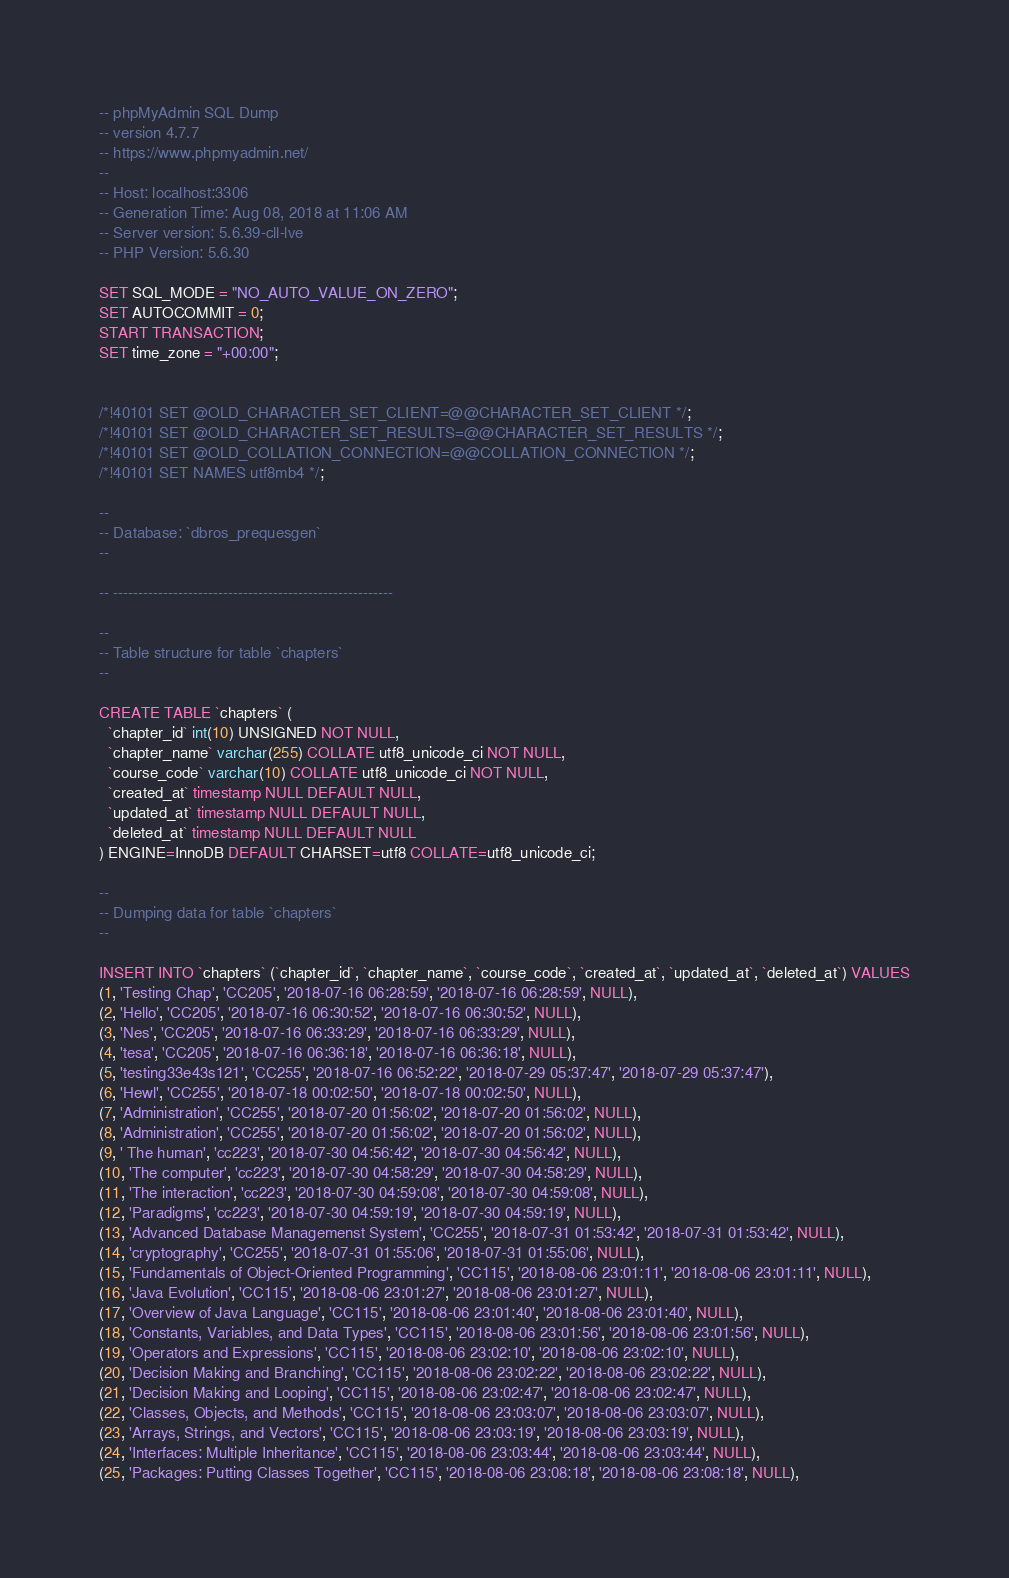<code> <loc_0><loc_0><loc_500><loc_500><_SQL_>-- phpMyAdmin SQL Dump
-- version 4.7.7
-- https://www.phpmyadmin.net/
--
-- Host: localhost:3306
-- Generation Time: Aug 08, 2018 at 11:06 AM
-- Server version: 5.6.39-cll-lve
-- PHP Version: 5.6.30

SET SQL_MODE = "NO_AUTO_VALUE_ON_ZERO";
SET AUTOCOMMIT = 0;
START TRANSACTION;
SET time_zone = "+00:00";


/*!40101 SET @OLD_CHARACTER_SET_CLIENT=@@CHARACTER_SET_CLIENT */;
/*!40101 SET @OLD_CHARACTER_SET_RESULTS=@@CHARACTER_SET_RESULTS */;
/*!40101 SET @OLD_COLLATION_CONNECTION=@@COLLATION_CONNECTION */;
/*!40101 SET NAMES utf8mb4 */;

--
-- Database: `dbros_prequesgen`
--

-- --------------------------------------------------------

--
-- Table structure for table `chapters`
--

CREATE TABLE `chapters` (
  `chapter_id` int(10) UNSIGNED NOT NULL,
  `chapter_name` varchar(255) COLLATE utf8_unicode_ci NOT NULL,
  `course_code` varchar(10) COLLATE utf8_unicode_ci NOT NULL,
  `created_at` timestamp NULL DEFAULT NULL,
  `updated_at` timestamp NULL DEFAULT NULL,
  `deleted_at` timestamp NULL DEFAULT NULL
) ENGINE=InnoDB DEFAULT CHARSET=utf8 COLLATE=utf8_unicode_ci;

--
-- Dumping data for table `chapters`
--

INSERT INTO `chapters` (`chapter_id`, `chapter_name`, `course_code`, `created_at`, `updated_at`, `deleted_at`) VALUES
(1, 'Testing Chap', 'CC205', '2018-07-16 06:28:59', '2018-07-16 06:28:59', NULL),
(2, 'Hello', 'CC205', '2018-07-16 06:30:52', '2018-07-16 06:30:52', NULL),
(3, 'Nes', 'CC205', '2018-07-16 06:33:29', '2018-07-16 06:33:29', NULL),
(4, 'tesa', 'CC205', '2018-07-16 06:36:18', '2018-07-16 06:36:18', NULL),
(5, 'testing33e43s121', 'CC255', '2018-07-16 06:52:22', '2018-07-29 05:37:47', '2018-07-29 05:37:47'),
(6, 'Hewl', 'CC255', '2018-07-18 00:02:50', '2018-07-18 00:02:50', NULL),
(7, 'Administration', 'CC255', '2018-07-20 01:56:02', '2018-07-20 01:56:02', NULL),
(8, 'Administration', 'CC255', '2018-07-20 01:56:02', '2018-07-20 01:56:02', NULL),
(9, ' The human', 'cc223', '2018-07-30 04:56:42', '2018-07-30 04:56:42', NULL),
(10, 'The computer', 'cc223', '2018-07-30 04:58:29', '2018-07-30 04:58:29', NULL),
(11, 'The interaction', 'cc223', '2018-07-30 04:59:08', '2018-07-30 04:59:08', NULL),
(12, 'Paradigms', 'cc223', '2018-07-30 04:59:19', '2018-07-30 04:59:19', NULL),
(13, 'Advanced Database Managemenst System', 'CC255', '2018-07-31 01:53:42', '2018-07-31 01:53:42', NULL),
(14, 'cryptography', 'CC255', '2018-07-31 01:55:06', '2018-07-31 01:55:06', NULL),
(15, 'Fundamentals of Object-Oriented Programming', 'CC115', '2018-08-06 23:01:11', '2018-08-06 23:01:11', NULL),
(16, 'Java Evolution', 'CC115', '2018-08-06 23:01:27', '2018-08-06 23:01:27', NULL),
(17, 'Overview of Java Language', 'CC115', '2018-08-06 23:01:40', '2018-08-06 23:01:40', NULL),
(18, 'Constants, Variables, and Data Types', 'CC115', '2018-08-06 23:01:56', '2018-08-06 23:01:56', NULL),
(19, 'Operators and Expressions', 'CC115', '2018-08-06 23:02:10', '2018-08-06 23:02:10', NULL),
(20, 'Decision Making and Branching', 'CC115', '2018-08-06 23:02:22', '2018-08-06 23:02:22', NULL),
(21, 'Decision Making and Looping', 'CC115', '2018-08-06 23:02:47', '2018-08-06 23:02:47', NULL),
(22, 'Classes, Objects, and Methods', 'CC115', '2018-08-06 23:03:07', '2018-08-06 23:03:07', NULL),
(23, 'Arrays, Strings, and Vectors', 'CC115', '2018-08-06 23:03:19', '2018-08-06 23:03:19', NULL),
(24, 'Interfaces: Multiple Inheritance', 'CC115', '2018-08-06 23:03:44', '2018-08-06 23:03:44', NULL),
(25, 'Packages: Putting Classes Together', 'CC115', '2018-08-06 23:08:18', '2018-08-06 23:08:18', NULL),</code> 